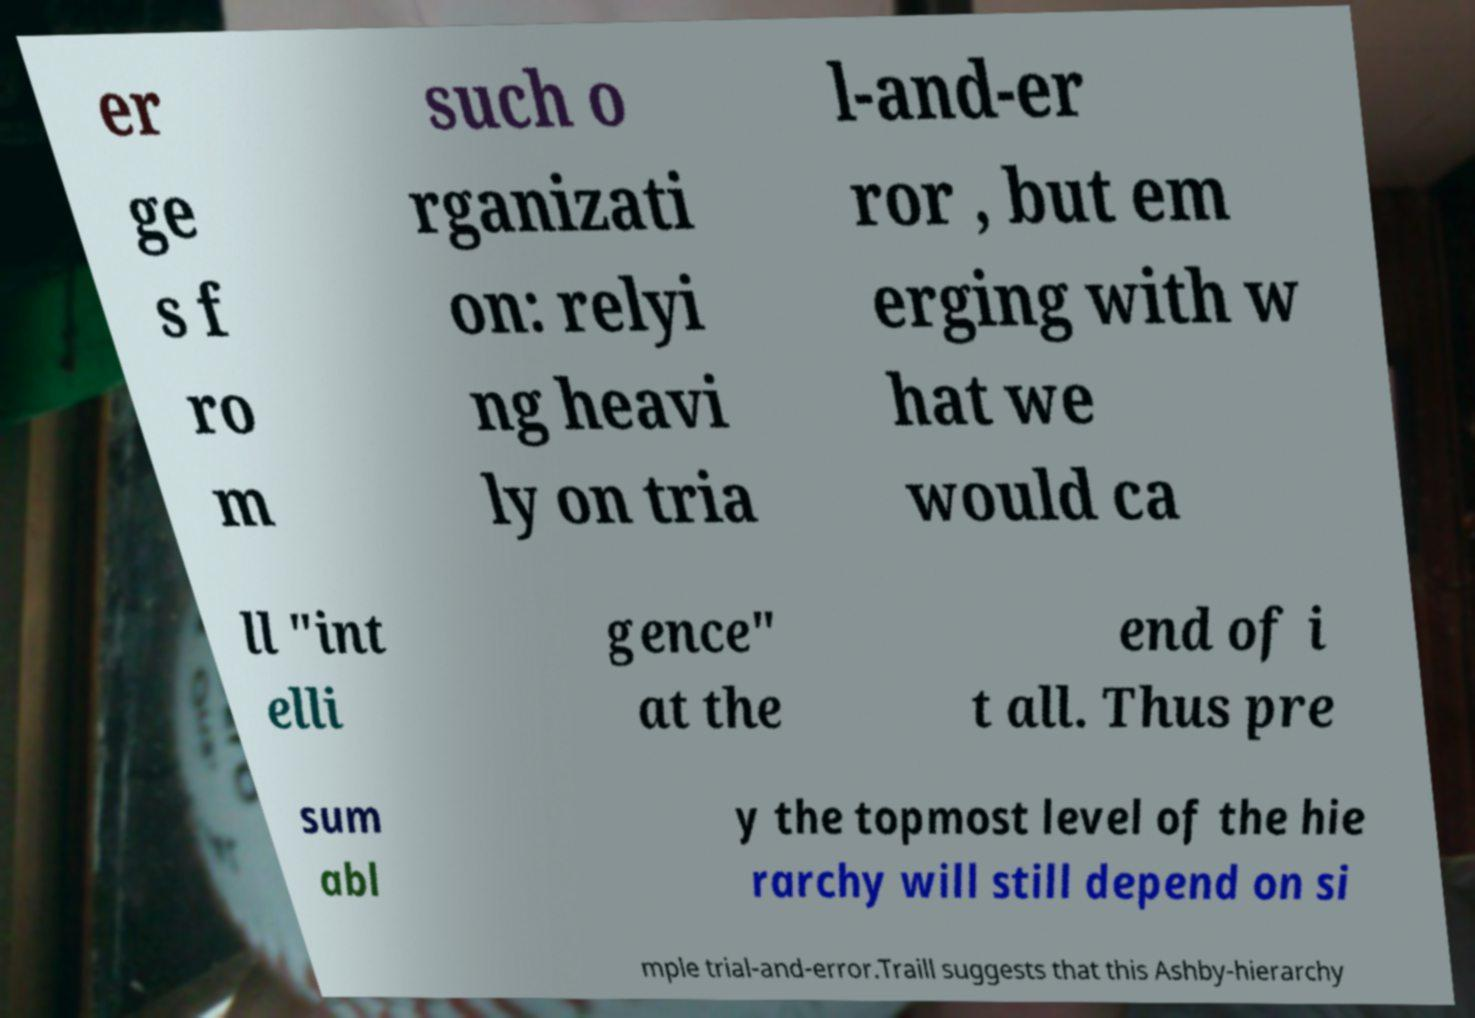Please identify and transcribe the text found in this image. er ge s f ro m such o rganizati on: relyi ng heavi ly on tria l-and-er ror , but em erging with w hat we would ca ll "int elli gence" at the end of i t all. Thus pre sum abl y the topmost level of the hie rarchy will still depend on si mple trial-and-error.Traill suggests that this Ashby-hierarchy 